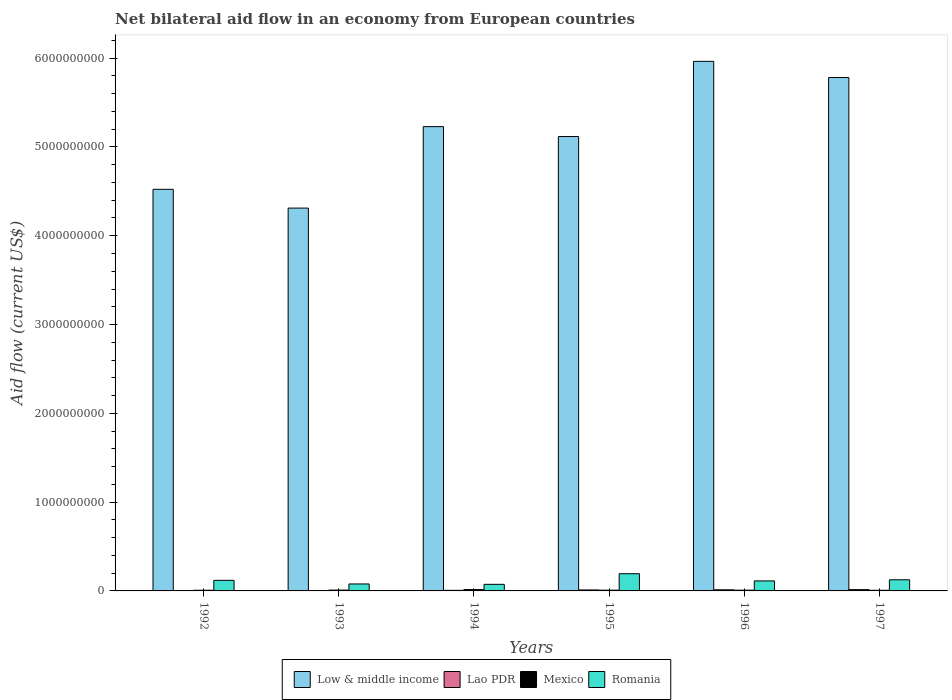How many different coloured bars are there?
Give a very brief answer. 4. How many bars are there on the 6th tick from the left?
Keep it short and to the point. 4. In how many cases, is the number of bars for a given year not equal to the number of legend labels?
Ensure brevity in your answer.  0. What is the net bilateral aid flow in Low & middle income in 1993?
Give a very brief answer. 4.31e+09. Across all years, what is the maximum net bilateral aid flow in Lao PDR?
Your answer should be very brief. 1.47e+07. Across all years, what is the minimum net bilateral aid flow in Low & middle income?
Offer a terse response. 4.31e+09. In which year was the net bilateral aid flow in Low & middle income minimum?
Provide a succinct answer. 1993. What is the total net bilateral aid flow in Mexico in the graph?
Your answer should be compact. 5.62e+07. What is the difference between the net bilateral aid flow in Lao PDR in 1995 and that in 1997?
Keep it short and to the point. -3.77e+06. What is the difference between the net bilateral aid flow in Low & middle income in 1994 and the net bilateral aid flow in Mexico in 1995?
Keep it short and to the point. 5.22e+09. What is the average net bilateral aid flow in Low & middle income per year?
Provide a short and direct response. 5.15e+09. In the year 1992, what is the difference between the net bilateral aid flow in Low & middle income and net bilateral aid flow in Romania?
Make the answer very short. 4.40e+09. In how many years, is the net bilateral aid flow in Romania greater than 5800000000 US$?
Your answer should be compact. 0. What is the ratio of the net bilateral aid flow in Lao PDR in 1995 to that in 1997?
Your answer should be very brief. 0.74. What is the difference between the highest and the second highest net bilateral aid flow in Romania?
Make the answer very short. 6.85e+07. What is the difference between the highest and the lowest net bilateral aid flow in Mexico?
Ensure brevity in your answer.  7.56e+06. In how many years, is the net bilateral aid flow in Low & middle income greater than the average net bilateral aid flow in Low & middle income taken over all years?
Ensure brevity in your answer.  3. Is the sum of the net bilateral aid flow in Mexico in 1996 and 1997 greater than the maximum net bilateral aid flow in Lao PDR across all years?
Provide a succinct answer. Yes. What does the 4th bar from the left in 1993 represents?
Your answer should be very brief. Romania. Is it the case that in every year, the sum of the net bilateral aid flow in Lao PDR and net bilateral aid flow in Mexico is greater than the net bilateral aid flow in Romania?
Ensure brevity in your answer.  No. Are all the bars in the graph horizontal?
Provide a succinct answer. No. How many years are there in the graph?
Offer a terse response. 6. What is the difference between two consecutive major ticks on the Y-axis?
Ensure brevity in your answer.  1.00e+09. What is the title of the graph?
Give a very brief answer. Net bilateral aid flow in an economy from European countries. Does "Caribbean small states" appear as one of the legend labels in the graph?
Give a very brief answer. No. What is the label or title of the Y-axis?
Offer a terse response. Aid flow (current US$). What is the Aid flow (current US$) of Low & middle income in 1992?
Provide a succinct answer. 4.52e+09. What is the Aid flow (current US$) in Lao PDR in 1992?
Make the answer very short. 3.07e+06. What is the Aid flow (current US$) in Mexico in 1992?
Make the answer very short. 7.63e+06. What is the Aid flow (current US$) of Romania in 1992?
Your answer should be very brief. 1.19e+08. What is the Aid flow (current US$) of Low & middle income in 1993?
Ensure brevity in your answer.  4.31e+09. What is the Aid flow (current US$) of Lao PDR in 1993?
Your answer should be compact. 3.56e+06. What is the Aid flow (current US$) of Mexico in 1993?
Keep it short and to the point. 9.34e+06. What is the Aid flow (current US$) in Romania in 1993?
Provide a short and direct response. 7.84e+07. What is the Aid flow (current US$) in Low & middle income in 1994?
Keep it short and to the point. 5.23e+09. What is the Aid flow (current US$) in Lao PDR in 1994?
Keep it short and to the point. 6.52e+06. What is the Aid flow (current US$) in Mexico in 1994?
Provide a short and direct response. 1.49e+07. What is the Aid flow (current US$) in Romania in 1994?
Provide a succinct answer. 7.42e+07. What is the Aid flow (current US$) in Low & middle income in 1995?
Give a very brief answer. 5.12e+09. What is the Aid flow (current US$) of Lao PDR in 1995?
Offer a terse response. 1.10e+07. What is the Aid flow (current US$) in Mexico in 1995?
Make the answer very short. 8.44e+06. What is the Aid flow (current US$) of Romania in 1995?
Your answer should be compact. 1.94e+08. What is the Aid flow (current US$) of Low & middle income in 1996?
Provide a short and direct response. 5.96e+09. What is the Aid flow (current US$) of Lao PDR in 1996?
Your response must be concise. 1.28e+07. What is the Aid flow (current US$) in Mexico in 1996?
Make the answer very short. 8.50e+06. What is the Aid flow (current US$) of Romania in 1996?
Make the answer very short. 1.13e+08. What is the Aid flow (current US$) of Low & middle income in 1997?
Your answer should be very brief. 5.78e+09. What is the Aid flow (current US$) of Lao PDR in 1997?
Keep it short and to the point. 1.47e+07. What is the Aid flow (current US$) of Mexico in 1997?
Give a very brief answer. 7.37e+06. What is the Aid flow (current US$) of Romania in 1997?
Provide a short and direct response. 1.25e+08. Across all years, what is the maximum Aid flow (current US$) of Low & middle income?
Your answer should be very brief. 5.96e+09. Across all years, what is the maximum Aid flow (current US$) in Lao PDR?
Ensure brevity in your answer.  1.47e+07. Across all years, what is the maximum Aid flow (current US$) in Mexico?
Provide a succinct answer. 1.49e+07. Across all years, what is the maximum Aid flow (current US$) of Romania?
Give a very brief answer. 1.94e+08. Across all years, what is the minimum Aid flow (current US$) in Low & middle income?
Make the answer very short. 4.31e+09. Across all years, what is the minimum Aid flow (current US$) in Lao PDR?
Provide a short and direct response. 3.07e+06. Across all years, what is the minimum Aid flow (current US$) in Mexico?
Your response must be concise. 7.37e+06. Across all years, what is the minimum Aid flow (current US$) in Romania?
Your response must be concise. 7.42e+07. What is the total Aid flow (current US$) in Low & middle income in the graph?
Offer a terse response. 3.09e+1. What is the total Aid flow (current US$) of Lao PDR in the graph?
Ensure brevity in your answer.  5.16e+07. What is the total Aid flow (current US$) in Mexico in the graph?
Offer a terse response. 5.62e+07. What is the total Aid flow (current US$) in Romania in the graph?
Your answer should be very brief. 7.04e+08. What is the difference between the Aid flow (current US$) in Low & middle income in 1992 and that in 1993?
Your answer should be compact. 2.11e+08. What is the difference between the Aid flow (current US$) of Lao PDR in 1992 and that in 1993?
Provide a short and direct response. -4.90e+05. What is the difference between the Aid flow (current US$) in Mexico in 1992 and that in 1993?
Offer a terse response. -1.71e+06. What is the difference between the Aid flow (current US$) in Romania in 1992 and that in 1993?
Give a very brief answer. 4.08e+07. What is the difference between the Aid flow (current US$) in Low & middle income in 1992 and that in 1994?
Make the answer very short. -7.06e+08. What is the difference between the Aid flow (current US$) in Lao PDR in 1992 and that in 1994?
Ensure brevity in your answer.  -3.45e+06. What is the difference between the Aid flow (current US$) in Mexico in 1992 and that in 1994?
Ensure brevity in your answer.  -7.30e+06. What is the difference between the Aid flow (current US$) in Romania in 1992 and that in 1994?
Your response must be concise. 4.50e+07. What is the difference between the Aid flow (current US$) of Low & middle income in 1992 and that in 1995?
Keep it short and to the point. -5.94e+08. What is the difference between the Aid flow (current US$) in Lao PDR in 1992 and that in 1995?
Offer a terse response. -7.88e+06. What is the difference between the Aid flow (current US$) in Mexico in 1992 and that in 1995?
Offer a very short reply. -8.10e+05. What is the difference between the Aid flow (current US$) of Romania in 1992 and that in 1995?
Provide a short and direct response. -7.46e+07. What is the difference between the Aid flow (current US$) of Low & middle income in 1992 and that in 1996?
Make the answer very short. -1.44e+09. What is the difference between the Aid flow (current US$) of Lao PDR in 1992 and that in 1996?
Provide a short and direct response. -9.73e+06. What is the difference between the Aid flow (current US$) in Mexico in 1992 and that in 1996?
Your response must be concise. -8.70e+05. What is the difference between the Aid flow (current US$) in Romania in 1992 and that in 1996?
Make the answer very short. 6.60e+06. What is the difference between the Aid flow (current US$) of Low & middle income in 1992 and that in 1997?
Make the answer very short. -1.26e+09. What is the difference between the Aid flow (current US$) of Lao PDR in 1992 and that in 1997?
Offer a very short reply. -1.16e+07. What is the difference between the Aid flow (current US$) in Mexico in 1992 and that in 1997?
Offer a very short reply. 2.60e+05. What is the difference between the Aid flow (current US$) in Romania in 1992 and that in 1997?
Give a very brief answer. -6.14e+06. What is the difference between the Aid flow (current US$) in Low & middle income in 1993 and that in 1994?
Your answer should be compact. -9.17e+08. What is the difference between the Aid flow (current US$) in Lao PDR in 1993 and that in 1994?
Make the answer very short. -2.96e+06. What is the difference between the Aid flow (current US$) in Mexico in 1993 and that in 1994?
Your answer should be very brief. -5.59e+06. What is the difference between the Aid flow (current US$) in Romania in 1993 and that in 1994?
Provide a short and direct response. 4.27e+06. What is the difference between the Aid flow (current US$) in Low & middle income in 1993 and that in 1995?
Your answer should be very brief. -8.06e+08. What is the difference between the Aid flow (current US$) in Lao PDR in 1993 and that in 1995?
Your answer should be very brief. -7.39e+06. What is the difference between the Aid flow (current US$) in Romania in 1993 and that in 1995?
Your answer should be very brief. -1.15e+08. What is the difference between the Aid flow (current US$) of Low & middle income in 1993 and that in 1996?
Your response must be concise. -1.65e+09. What is the difference between the Aid flow (current US$) in Lao PDR in 1993 and that in 1996?
Your answer should be very brief. -9.24e+06. What is the difference between the Aid flow (current US$) in Mexico in 1993 and that in 1996?
Offer a terse response. 8.40e+05. What is the difference between the Aid flow (current US$) of Romania in 1993 and that in 1996?
Offer a terse response. -3.42e+07. What is the difference between the Aid flow (current US$) in Low & middle income in 1993 and that in 1997?
Offer a terse response. -1.47e+09. What is the difference between the Aid flow (current US$) of Lao PDR in 1993 and that in 1997?
Give a very brief answer. -1.12e+07. What is the difference between the Aid flow (current US$) in Mexico in 1993 and that in 1997?
Provide a short and direct response. 1.97e+06. What is the difference between the Aid flow (current US$) in Romania in 1993 and that in 1997?
Provide a short and direct response. -4.69e+07. What is the difference between the Aid flow (current US$) in Low & middle income in 1994 and that in 1995?
Provide a succinct answer. 1.12e+08. What is the difference between the Aid flow (current US$) of Lao PDR in 1994 and that in 1995?
Your answer should be very brief. -4.43e+06. What is the difference between the Aid flow (current US$) of Mexico in 1994 and that in 1995?
Your response must be concise. 6.49e+06. What is the difference between the Aid flow (current US$) in Romania in 1994 and that in 1995?
Keep it short and to the point. -1.20e+08. What is the difference between the Aid flow (current US$) in Low & middle income in 1994 and that in 1996?
Offer a very short reply. -7.35e+08. What is the difference between the Aid flow (current US$) in Lao PDR in 1994 and that in 1996?
Offer a terse response. -6.28e+06. What is the difference between the Aid flow (current US$) of Mexico in 1994 and that in 1996?
Your response must be concise. 6.43e+06. What is the difference between the Aid flow (current US$) in Romania in 1994 and that in 1996?
Offer a terse response. -3.84e+07. What is the difference between the Aid flow (current US$) in Low & middle income in 1994 and that in 1997?
Offer a very short reply. -5.53e+08. What is the difference between the Aid flow (current US$) of Lao PDR in 1994 and that in 1997?
Offer a terse response. -8.20e+06. What is the difference between the Aid flow (current US$) in Mexico in 1994 and that in 1997?
Offer a terse response. 7.56e+06. What is the difference between the Aid flow (current US$) of Romania in 1994 and that in 1997?
Your answer should be very brief. -5.12e+07. What is the difference between the Aid flow (current US$) in Low & middle income in 1995 and that in 1996?
Make the answer very short. -8.47e+08. What is the difference between the Aid flow (current US$) of Lao PDR in 1995 and that in 1996?
Offer a terse response. -1.85e+06. What is the difference between the Aid flow (current US$) in Romania in 1995 and that in 1996?
Offer a very short reply. 8.12e+07. What is the difference between the Aid flow (current US$) of Low & middle income in 1995 and that in 1997?
Offer a very short reply. -6.64e+08. What is the difference between the Aid flow (current US$) in Lao PDR in 1995 and that in 1997?
Give a very brief answer. -3.77e+06. What is the difference between the Aid flow (current US$) in Mexico in 1995 and that in 1997?
Keep it short and to the point. 1.07e+06. What is the difference between the Aid flow (current US$) of Romania in 1995 and that in 1997?
Your answer should be very brief. 6.85e+07. What is the difference between the Aid flow (current US$) in Low & middle income in 1996 and that in 1997?
Provide a short and direct response. 1.82e+08. What is the difference between the Aid flow (current US$) in Lao PDR in 1996 and that in 1997?
Keep it short and to the point. -1.92e+06. What is the difference between the Aid flow (current US$) in Mexico in 1996 and that in 1997?
Offer a very short reply. 1.13e+06. What is the difference between the Aid flow (current US$) in Romania in 1996 and that in 1997?
Provide a short and direct response. -1.27e+07. What is the difference between the Aid flow (current US$) in Low & middle income in 1992 and the Aid flow (current US$) in Lao PDR in 1993?
Offer a terse response. 4.52e+09. What is the difference between the Aid flow (current US$) of Low & middle income in 1992 and the Aid flow (current US$) of Mexico in 1993?
Provide a short and direct response. 4.51e+09. What is the difference between the Aid flow (current US$) of Low & middle income in 1992 and the Aid flow (current US$) of Romania in 1993?
Your answer should be very brief. 4.44e+09. What is the difference between the Aid flow (current US$) in Lao PDR in 1992 and the Aid flow (current US$) in Mexico in 1993?
Provide a short and direct response. -6.27e+06. What is the difference between the Aid flow (current US$) of Lao PDR in 1992 and the Aid flow (current US$) of Romania in 1993?
Keep it short and to the point. -7.54e+07. What is the difference between the Aid flow (current US$) of Mexico in 1992 and the Aid flow (current US$) of Romania in 1993?
Your answer should be very brief. -7.08e+07. What is the difference between the Aid flow (current US$) in Low & middle income in 1992 and the Aid flow (current US$) in Lao PDR in 1994?
Provide a short and direct response. 4.52e+09. What is the difference between the Aid flow (current US$) in Low & middle income in 1992 and the Aid flow (current US$) in Mexico in 1994?
Your answer should be compact. 4.51e+09. What is the difference between the Aid flow (current US$) of Low & middle income in 1992 and the Aid flow (current US$) of Romania in 1994?
Provide a succinct answer. 4.45e+09. What is the difference between the Aid flow (current US$) of Lao PDR in 1992 and the Aid flow (current US$) of Mexico in 1994?
Keep it short and to the point. -1.19e+07. What is the difference between the Aid flow (current US$) of Lao PDR in 1992 and the Aid flow (current US$) of Romania in 1994?
Offer a terse response. -7.11e+07. What is the difference between the Aid flow (current US$) of Mexico in 1992 and the Aid flow (current US$) of Romania in 1994?
Ensure brevity in your answer.  -6.66e+07. What is the difference between the Aid flow (current US$) in Low & middle income in 1992 and the Aid flow (current US$) in Lao PDR in 1995?
Ensure brevity in your answer.  4.51e+09. What is the difference between the Aid flow (current US$) in Low & middle income in 1992 and the Aid flow (current US$) in Mexico in 1995?
Your answer should be compact. 4.51e+09. What is the difference between the Aid flow (current US$) in Low & middle income in 1992 and the Aid flow (current US$) in Romania in 1995?
Offer a terse response. 4.33e+09. What is the difference between the Aid flow (current US$) of Lao PDR in 1992 and the Aid flow (current US$) of Mexico in 1995?
Provide a short and direct response. -5.37e+06. What is the difference between the Aid flow (current US$) of Lao PDR in 1992 and the Aid flow (current US$) of Romania in 1995?
Provide a short and direct response. -1.91e+08. What is the difference between the Aid flow (current US$) of Mexico in 1992 and the Aid flow (current US$) of Romania in 1995?
Ensure brevity in your answer.  -1.86e+08. What is the difference between the Aid flow (current US$) of Low & middle income in 1992 and the Aid flow (current US$) of Lao PDR in 1996?
Your answer should be compact. 4.51e+09. What is the difference between the Aid flow (current US$) in Low & middle income in 1992 and the Aid flow (current US$) in Mexico in 1996?
Your response must be concise. 4.51e+09. What is the difference between the Aid flow (current US$) of Low & middle income in 1992 and the Aid flow (current US$) of Romania in 1996?
Offer a very short reply. 4.41e+09. What is the difference between the Aid flow (current US$) of Lao PDR in 1992 and the Aid flow (current US$) of Mexico in 1996?
Give a very brief answer. -5.43e+06. What is the difference between the Aid flow (current US$) in Lao PDR in 1992 and the Aid flow (current US$) in Romania in 1996?
Give a very brief answer. -1.10e+08. What is the difference between the Aid flow (current US$) of Mexico in 1992 and the Aid flow (current US$) of Romania in 1996?
Provide a succinct answer. -1.05e+08. What is the difference between the Aid flow (current US$) of Low & middle income in 1992 and the Aid flow (current US$) of Lao PDR in 1997?
Offer a terse response. 4.51e+09. What is the difference between the Aid flow (current US$) in Low & middle income in 1992 and the Aid flow (current US$) in Mexico in 1997?
Ensure brevity in your answer.  4.52e+09. What is the difference between the Aid flow (current US$) of Low & middle income in 1992 and the Aid flow (current US$) of Romania in 1997?
Give a very brief answer. 4.40e+09. What is the difference between the Aid flow (current US$) in Lao PDR in 1992 and the Aid flow (current US$) in Mexico in 1997?
Provide a succinct answer. -4.30e+06. What is the difference between the Aid flow (current US$) of Lao PDR in 1992 and the Aid flow (current US$) of Romania in 1997?
Provide a short and direct response. -1.22e+08. What is the difference between the Aid flow (current US$) in Mexico in 1992 and the Aid flow (current US$) in Romania in 1997?
Give a very brief answer. -1.18e+08. What is the difference between the Aid flow (current US$) in Low & middle income in 1993 and the Aid flow (current US$) in Lao PDR in 1994?
Your response must be concise. 4.30e+09. What is the difference between the Aid flow (current US$) of Low & middle income in 1993 and the Aid flow (current US$) of Mexico in 1994?
Make the answer very short. 4.30e+09. What is the difference between the Aid flow (current US$) in Low & middle income in 1993 and the Aid flow (current US$) in Romania in 1994?
Give a very brief answer. 4.24e+09. What is the difference between the Aid flow (current US$) in Lao PDR in 1993 and the Aid flow (current US$) in Mexico in 1994?
Ensure brevity in your answer.  -1.14e+07. What is the difference between the Aid flow (current US$) of Lao PDR in 1993 and the Aid flow (current US$) of Romania in 1994?
Provide a short and direct response. -7.06e+07. What is the difference between the Aid flow (current US$) of Mexico in 1993 and the Aid flow (current US$) of Romania in 1994?
Ensure brevity in your answer.  -6.48e+07. What is the difference between the Aid flow (current US$) in Low & middle income in 1993 and the Aid flow (current US$) in Lao PDR in 1995?
Your answer should be very brief. 4.30e+09. What is the difference between the Aid flow (current US$) of Low & middle income in 1993 and the Aid flow (current US$) of Mexico in 1995?
Your answer should be compact. 4.30e+09. What is the difference between the Aid flow (current US$) of Low & middle income in 1993 and the Aid flow (current US$) of Romania in 1995?
Your response must be concise. 4.12e+09. What is the difference between the Aid flow (current US$) of Lao PDR in 1993 and the Aid flow (current US$) of Mexico in 1995?
Ensure brevity in your answer.  -4.88e+06. What is the difference between the Aid flow (current US$) in Lao PDR in 1993 and the Aid flow (current US$) in Romania in 1995?
Give a very brief answer. -1.90e+08. What is the difference between the Aid flow (current US$) of Mexico in 1993 and the Aid flow (current US$) of Romania in 1995?
Provide a succinct answer. -1.85e+08. What is the difference between the Aid flow (current US$) of Low & middle income in 1993 and the Aid flow (current US$) of Lao PDR in 1996?
Make the answer very short. 4.30e+09. What is the difference between the Aid flow (current US$) of Low & middle income in 1993 and the Aid flow (current US$) of Mexico in 1996?
Offer a very short reply. 4.30e+09. What is the difference between the Aid flow (current US$) in Low & middle income in 1993 and the Aid flow (current US$) in Romania in 1996?
Your answer should be compact. 4.20e+09. What is the difference between the Aid flow (current US$) of Lao PDR in 1993 and the Aid flow (current US$) of Mexico in 1996?
Your response must be concise. -4.94e+06. What is the difference between the Aid flow (current US$) of Lao PDR in 1993 and the Aid flow (current US$) of Romania in 1996?
Give a very brief answer. -1.09e+08. What is the difference between the Aid flow (current US$) in Mexico in 1993 and the Aid flow (current US$) in Romania in 1996?
Your answer should be compact. -1.03e+08. What is the difference between the Aid flow (current US$) in Low & middle income in 1993 and the Aid flow (current US$) in Lao PDR in 1997?
Provide a succinct answer. 4.30e+09. What is the difference between the Aid flow (current US$) of Low & middle income in 1993 and the Aid flow (current US$) of Mexico in 1997?
Provide a succinct answer. 4.30e+09. What is the difference between the Aid flow (current US$) of Low & middle income in 1993 and the Aid flow (current US$) of Romania in 1997?
Ensure brevity in your answer.  4.19e+09. What is the difference between the Aid flow (current US$) in Lao PDR in 1993 and the Aid flow (current US$) in Mexico in 1997?
Your response must be concise. -3.81e+06. What is the difference between the Aid flow (current US$) of Lao PDR in 1993 and the Aid flow (current US$) of Romania in 1997?
Make the answer very short. -1.22e+08. What is the difference between the Aid flow (current US$) in Mexico in 1993 and the Aid flow (current US$) in Romania in 1997?
Make the answer very short. -1.16e+08. What is the difference between the Aid flow (current US$) in Low & middle income in 1994 and the Aid flow (current US$) in Lao PDR in 1995?
Provide a succinct answer. 5.22e+09. What is the difference between the Aid flow (current US$) of Low & middle income in 1994 and the Aid flow (current US$) of Mexico in 1995?
Offer a very short reply. 5.22e+09. What is the difference between the Aid flow (current US$) in Low & middle income in 1994 and the Aid flow (current US$) in Romania in 1995?
Your answer should be very brief. 5.03e+09. What is the difference between the Aid flow (current US$) in Lao PDR in 1994 and the Aid flow (current US$) in Mexico in 1995?
Offer a terse response. -1.92e+06. What is the difference between the Aid flow (current US$) of Lao PDR in 1994 and the Aid flow (current US$) of Romania in 1995?
Make the answer very short. -1.87e+08. What is the difference between the Aid flow (current US$) in Mexico in 1994 and the Aid flow (current US$) in Romania in 1995?
Your answer should be compact. -1.79e+08. What is the difference between the Aid flow (current US$) in Low & middle income in 1994 and the Aid flow (current US$) in Lao PDR in 1996?
Offer a very short reply. 5.22e+09. What is the difference between the Aid flow (current US$) of Low & middle income in 1994 and the Aid flow (current US$) of Mexico in 1996?
Offer a terse response. 5.22e+09. What is the difference between the Aid flow (current US$) of Low & middle income in 1994 and the Aid flow (current US$) of Romania in 1996?
Keep it short and to the point. 5.12e+09. What is the difference between the Aid flow (current US$) in Lao PDR in 1994 and the Aid flow (current US$) in Mexico in 1996?
Your response must be concise. -1.98e+06. What is the difference between the Aid flow (current US$) in Lao PDR in 1994 and the Aid flow (current US$) in Romania in 1996?
Provide a short and direct response. -1.06e+08. What is the difference between the Aid flow (current US$) in Mexico in 1994 and the Aid flow (current US$) in Romania in 1996?
Offer a terse response. -9.77e+07. What is the difference between the Aid flow (current US$) in Low & middle income in 1994 and the Aid flow (current US$) in Lao PDR in 1997?
Give a very brief answer. 5.21e+09. What is the difference between the Aid flow (current US$) of Low & middle income in 1994 and the Aid flow (current US$) of Mexico in 1997?
Offer a terse response. 5.22e+09. What is the difference between the Aid flow (current US$) in Low & middle income in 1994 and the Aid flow (current US$) in Romania in 1997?
Offer a terse response. 5.10e+09. What is the difference between the Aid flow (current US$) in Lao PDR in 1994 and the Aid flow (current US$) in Mexico in 1997?
Offer a terse response. -8.50e+05. What is the difference between the Aid flow (current US$) in Lao PDR in 1994 and the Aid flow (current US$) in Romania in 1997?
Keep it short and to the point. -1.19e+08. What is the difference between the Aid flow (current US$) of Mexico in 1994 and the Aid flow (current US$) of Romania in 1997?
Provide a short and direct response. -1.10e+08. What is the difference between the Aid flow (current US$) in Low & middle income in 1995 and the Aid flow (current US$) in Lao PDR in 1996?
Your response must be concise. 5.10e+09. What is the difference between the Aid flow (current US$) of Low & middle income in 1995 and the Aid flow (current US$) of Mexico in 1996?
Offer a very short reply. 5.11e+09. What is the difference between the Aid flow (current US$) of Low & middle income in 1995 and the Aid flow (current US$) of Romania in 1996?
Your response must be concise. 5.00e+09. What is the difference between the Aid flow (current US$) of Lao PDR in 1995 and the Aid flow (current US$) of Mexico in 1996?
Provide a short and direct response. 2.45e+06. What is the difference between the Aid flow (current US$) in Lao PDR in 1995 and the Aid flow (current US$) in Romania in 1996?
Give a very brief answer. -1.02e+08. What is the difference between the Aid flow (current US$) in Mexico in 1995 and the Aid flow (current US$) in Romania in 1996?
Your response must be concise. -1.04e+08. What is the difference between the Aid flow (current US$) in Low & middle income in 1995 and the Aid flow (current US$) in Lao PDR in 1997?
Your answer should be compact. 5.10e+09. What is the difference between the Aid flow (current US$) of Low & middle income in 1995 and the Aid flow (current US$) of Mexico in 1997?
Offer a very short reply. 5.11e+09. What is the difference between the Aid flow (current US$) of Low & middle income in 1995 and the Aid flow (current US$) of Romania in 1997?
Provide a succinct answer. 4.99e+09. What is the difference between the Aid flow (current US$) of Lao PDR in 1995 and the Aid flow (current US$) of Mexico in 1997?
Provide a short and direct response. 3.58e+06. What is the difference between the Aid flow (current US$) of Lao PDR in 1995 and the Aid flow (current US$) of Romania in 1997?
Your answer should be very brief. -1.14e+08. What is the difference between the Aid flow (current US$) in Mexico in 1995 and the Aid flow (current US$) in Romania in 1997?
Provide a short and direct response. -1.17e+08. What is the difference between the Aid flow (current US$) in Low & middle income in 1996 and the Aid flow (current US$) in Lao PDR in 1997?
Provide a short and direct response. 5.95e+09. What is the difference between the Aid flow (current US$) in Low & middle income in 1996 and the Aid flow (current US$) in Mexico in 1997?
Offer a very short reply. 5.96e+09. What is the difference between the Aid flow (current US$) of Low & middle income in 1996 and the Aid flow (current US$) of Romania in 1997?
Make the answer very short. 5.84e+09. What is the difference between the Aid flow (current US$) in Lao PDR in 1996 and the Aid flow (current US$) in Mexico in 1997?
Make the answer very short. 5.43e+06. What is the difference between the Aid flow (current US$) in Lao PDR in 1996 and the Aid flow (current US$) in Romania in 1997?
Offer a very short reply. -1.13e+08. What is the difference between the Aid flow (current US$) in Mexico in 1996 and the Aid flow (current US$) in Romania in 1997?
Keep it short and to the point. -1.17e+08. What is the average Aid flow (current US$) of Low & middle income per year?
Provide a short and direct response. 5.15e+09. What is the average Aid flow (current US$) of Lao PDR per year?
Provide a succinct answer. 8.60e+06. What is the average Aid flow (current US$) in Mexico per year?
Provide a succinct answer. 9.37e+06. What is the average Aid flow (current US$) of Romania per year?
Ensure brevity in your answer.  1.17e+08. In the year 1992, what is the difference between the Aid flow (current US$) in Low & middle income and Aid flow (current US$) in Lao PDR?
Your response must be concise. 4.52e+09. In the year 1992, what is the difference between the Aid flow (current US$) of Low & middle income and Aid flow (current US$) of Mexico?
Your response must be concise. 4.52e+09. In the year 1992, what is the difference between the Aid flow (current US$) of Low & middle income and Aid flow (current US$) of Romania?
Your response must be concise. 4.40e+09. In the year 1992, what is the difference between the Aid flow (current US$) in Lao PDR and Aid flow (current US$) in Mexico?
Provide a succinct answer. -4.56e+06. In the year 1992, what is the difference between the Aid flow (current US$) of Lao PDR and Aid flow (current US$) of Romania?
Offer a terse response. -1.16e+08. In the year 1992, what is the difference between the Aid flow (current US$) in Mexico and Aid flow (current US$) in Romania?
Provide a succinct answer. -1.12e+08. In the year 1993, what is the difference between the Aid flow (current US$) of Low & middle income and Aid flow (current US$) of Lao PDR?
Offer a very short reply. 4.31e+09. In the year 1993, what is the difference between the Aid flow (current US$) in Low & middle income and Aid flow (current US$) in Mexico?
Offer a very short reply. 4.30e+09. In the year 1993, what is the difference between the Aid flow (current US$) of Low & middle income and Aid flow (current US$) of Romania?
Your answer should be compact. 4.23e+09. In the year 1993, what is the difference between the Aid flow (current US$) in Lao PDR and Aid flow (current US$) in Mexico?
Your answer should be compact. -5.78e+06. In the year 1993, what is the difference between the Aid flow (current US$) in Lao PDR and Aid flow (current US$) in Romania?
Keep it short and to the point. -7.49e+07. In the year 1993, what is the difference between the Aid flow (current US$) in Mexico and Aid flow (current US$) in Romania?
Keep it short and to the point. -6.91e+07. In the year 1994, what is the difference between the Aid flow (current US$) in Low & middle income and Aid flow (current US$) in Lao PDR?
Offer a terse response. 5.22e+09. In the year 1994, what is the difference between the Aid flow (current US$) of Low & middle income and Aid flow (current US$) of Mexico?
Ensure brevity in your answer.  5.21e+09. In the year 1994, what is the difference between the Aid flow (current US$) in Low & middle income and Aid flow (current US$) in Romania?
Provide a short and direct response. 5.15e+09. In the year 1994, what is the difference between the Aid flow (current US$) in Lao PDR and Aid flow (current US$) in Mexico?
Offer a very short reply. -8.41e+06. In the year 1994, what is the difference between the Aid flow (current US$) in Lao PDR and Aid flow (current US$) in Romania?
Ensure brevity in your answer.  -6.77e+07. In the year 1994, what is the difference between the Aid flow (current US$) in Mexico and Aid flow (current US$) in Romania?
Keep it short and to the point. -5.92e+07. In the year 1995, what is the difference between the Aid flow (current US$) of Low & middle income and Aid flow (current US$) of Lao PDR?
Your answer should be compact. 5.11e+09. In the year 1995, what is the difference between the Aid flow (current US$) in Low & middle income and Aid flow (current US$) in Mexico?
Make the answer very short. 5.11e+09. In the year 1995, what is the difference between the Aid flow (current US$) of Low & middle income and Aid flow (current US$) of Romania?
Offer a terse response. 4.92e+09. In the year 1995, what is the difference between the Aid flow (current US$) of Lao PDR and Aid flow (current US$) of Mexico?
Provide a short and direct response. 2.51e+06. In the year 1995, what is the difference between the Aid flow (current US$) in Lao PDR and Aid flow (current US$) in Romania?
Your response must be concise. -1.83e+08. In the year 1995, what is the difference between the Aid flow (current US$) in Mexico and Aid flow (current US$) in Romania?
Provide a succinct answer. -1.85e+08. In the year 1996, what is the difference between the Aid flow (current US$) of Low & middle income and Aid flow (current US$) of Lao PDR?
Your response must be concise. 5.95e+09. In the year 1996, what is the difference between the Aid flow (current US$) of Low & middle income and Aid flow (current US$) of Mexico?
Ensure brevity in your answer.  5.96e+09. In the year 1996, what is the difference between the Aid flow (current US$) of Low & middle income and Aid flow (current US$) of Romania?
Your answer should be very brief. 5.85e+09. In the year 1996, what is the difference between the Aid flow (current US$) in Lao PDR and Aid flow (current US$) in Mexico?
Provide a succinct answer. 4.30e+06. In the year 1996, what is the difference between the Aid flow (current US$) of Lao PDR and Aid flow (current US$) of Romania?
Offer a terse response. -9.98e+07. In the year 1996, what is the difference between the Aid flow (current US$) in Mexico and Aid flow (current US$) in Romania?
Give a very brief answer. -1.04e+08. In the year 1997, what is the difference between the Aid flow (current US$) in Low & middle income and Aid flow (current US$) in Lao PDR?
Give a very brief answer. 5.77e+09. In the year 1997, what is the difference between the Aid flow (current US$) in Low & middle income and Aid flow (current US$) in Mexico?
Offer a terse response. 5.77e+09. In the year 1997, what is the difference between the Aid flow (current US$) in Low & middle income and Aid flow (current US$) in Romania?
Give a very brief answer. 5.66e+09. In the year 1997, what is the difference between the Aid flow (current US$) in Lao PDR and Aid flow (current US$) in Mexico?
Provide a succinct answer. 7.35e+06. In the year 1997, what is the difference between the Aid flow (current US$) in Lao PDR and Aid flow (current US$) in Romania?
Give a very brief answer. -1.11e+08. In the year 1997, what is the difference between the Aid flow (current US$) in Mexico and Aid flow (current US$) in Romania?
Your answer should be compact. -1.18e+08. What is the ratio of the Aid flow (current US$) of Low & middle income in 1992 to that in 1993?
Keep it short and to the point. 1.05. What is the ratio of the Aid flow (current US$) in Lao PDR in 1992 to that in 1993?
Offer a very short reply. 0.86. What is the ratio of the Aid flow (current US$) of Mexico in 1992 to that in 1993?
Provide a short and direct response. 0.82. What is the ratio of the Aid flow (current US$) in Romania in 1992 to that in 1993?
Provide a short and direct response. 1.52. What is the ratio of the Aid flow (current US$) of Low & middle income in 1992 to that in 1994?
Offer a terse response. 0.86. What is the ratio of the Aid flow (current US$) in Lao PDR in 1992 to that in 1994?
Provide a succinct answer. 0.47. What is the ratio of the Aid flow (current US$) of Mexico in 1992 to that in 1994?
Offer a terse response. 0.51. What is the ratio of the Aid flow (current US$) of Romania in 1992 to that in 1994?
Make the answer very short. 1.61. What is the ratio of the Aid flow (current US$) of Low & middle income in 1992 to that in 1995?
Ensure brevity in your answer.  0.88. What is the ratio of the Aid flow (current US$) in Lao PDR in 1992 to that in 1995?
Provide a succinct answer. 0.28. What is the ratio of the Aid flow (current US$) in Mexico in 1992 to that in 1995?
Keep it short and to the point. 0.9. What is the ratio of the Aid flow (current US$) in Romania in 1992 to that in 1995?
Ensure brevity in your answer.  0.61. What is the ratio of the Aid flow (current US$) of Low & middle income in 1992 to that in 1996?
Offer a terse response. 0.76. What is the ratio of the Aid flow (current US$) of Lao PDR in 1992 to that in 1996?
Your answer should be very brief. 0.24. What is the ratio of the Aid flow (current US$) in Mexico in 1992 to that in 1996?
Your answer should be very brief. 0.9. What is the ratio of the Aid flow (current US$) of Romania in 1992 to that in 1996?
Your response must be concise. 1.06. What is the ratio of the Aid flow (current US$) in Low & middle income in 1992 to that in 1997?
Provide a short and direct response. 0.78. What is the ratio of the Aid flow (current US$) of Lao PDR in 1992 to that in 1997?
Keep it short and to the point. 0.21. What is the ratio of the Aid flow (current US$) in Mexico in 1992 to that in 1997?
Your answer should be compact. 1.04. What is the ratio of the Aid flow (current US$) in Romania in 1992 to that in 1997?
Ensure brevity in your answer.  0.95. What is the ratio of the Aid flow (current US$) of Low & middle income in 1993 to that in 1994?
Ensure brevity in your answer.  0.82. What is the ratio of the Aid flow (current US$) in Lao PDR in 1993 to that in 1994?
Your response must be concise. 0.55. What is the ratio of the Aid flow (current US$) of Mexico in 1993 to that in 1994?
Provide a short and direct response. 0.63. What is the ratio of the Aid flow (current US$) in Romania in 1993 to that in 1994?
Your answer should be compact. 1.06. What is the ratio of the Aid flow (current US$) in Low & middle income in 1993 to that in 1995?
Provide a succinct answer. 0.84. What is the ratio of the Aid flow (current US$) of Lao PDR in 1993 to that in 1995?
Your answer should be very brief. 0.33. What is the ratio of the Aid flow (current US$) of Mexico in 1993 to that in 1995?
Keep it short and to the point. 1.11. What is the ratio of the Aid flow (current US$) of Romania in 1993 to that in 1995?
Provide a succinct answer. 0.4. What is the ratio of the Aid flow (current US$) of Low & middle income in 1993 to that in 1996?
Make the answer very short. 0.72. What is the ratio of the Aid flow (current US$) of Lao PDR in 1993 to that in 1996?
Your response must be concise. 0.28. What is the ratio of the Aid flow (current US$) of Mexico in 1993 to that in 1996?
Your response must be concise. 1.1. What is the ratio of the Aid flow (current US$) of Romania in 1993 to that in 1996?
Provide a succinct answer. 0.7. What is the ratio of the Aid flow (current US$) of Low & middle income in 1993 to that in 1997?
Keep it short and to the point. 0.75. What is the ratio of the Aid flow (current US$) of Lao PDR in 1993 to that in 1997?
Give a very brief answer. 0.24. What is the ratio of the Aid flow (current US$) in Mexico in 1993 to that in 1997?
Offer a very short reply. 1.27. What is the ratio of the Aid flow (current US$) in Romania in 1993 to that in 1997?
Offer a very short reply. 0.63. What is the ratio of the Aid flow (current US$) in Low & middle income in 1994 to that in 1995?
Your answer should be very brief. 1.02. What is the ratio of the Aid flow (current US$) of Lao PDR in 1994 to that in 1995?
Provide a succinct answer. 0.6. What is the ratio of the Aid flow (current US$) in Mexico in 1994 to that in 1995?
Your response must be concise. 1.77. What is the ratio of the Aid flow (current US$) of Romania in 1994 to that in 1995?
Offer a terse response. 0.38. What is the ratio of the Aid flow (current US$) in Low & middle income in 1994 to that in 1996?
Your answer should be very brief. 0.88. What is the ratio of the Aid flow (current US$) of Lao PDR in 1994 to that in 1996?
Give a very brief answer. 0.51. What is the ratio of the Aid flow (current US$) in Mexico in 1994 to that in 1996?
Offer a very short reply. 1.76. What is the ratio of the Aid flow (current US$) in Romania in 1994 to that in 1996?
Offer a terse response. 0.66. What is the ratio of the Aid flow (current US$) of Low & middle income in 1994 to that in 1997?
Make the answer very short. 0.9. What is the ratio of the Aid flow (current US$) in Lao PDR in 1994 to that in 1997?
Offer a terse response. 0.44. What is the ratio of the Aid flow (current US$) in Mexico in 1994 to that in 1997?
Ensure brevity in your answer.  2.03. What is the ratio of the Aid flow (current US$) of Romania in 1994 to that in 1997?
Offer a terse response. 0.59. What is the ratio of the Aid flow (current US$) of Low & middle income in 1995 to that in 1996?
Your answer should be compact. 0.86. What is the ratio of the Aid flow (current US$) of Lao PDR in 1995 to that in 1996?
Your answer should be very brief. 0.86. What is the ratio of the Aid flow (current US$) in Romania in 1995 to that in 1996?
Your response must be concise. 1.72. What is the ratio of the Aid flow (current US$) of Low & middle income in 1995 to that in 1997?
Offer a terse response. 0.89. What is the ratio of the Aid flow (current US$) of Lao PDR in 1995 to that in 1997?
Keep it short and to the point. 0.74. What is the ratio of the Aid flow (current US$) of Mexico in 1995 to that in 1997?
Your answer should be compact. 1.15. What is the ratio of the Aid flow (current US$) in Romania in 1995 to that in 1997?
Your answer should be compact. 1.55. What is the ratio of the Aid flow (current US$) of Low & middle income in 1996 to that in 1997?
Offer a terse response. 1.03. What is the ratio of the Aid flow (current US$) in Lao PDR in 1996 to that in 1997?
Your answer should be compact. 0.87. What is the ratio of the Aid flow (current US$) of Mexico in 1996 to that in 1997?
Ensure brevity in your answer.  1.15. What is the ratio of the Aid flow (current US$) of Romania in 1996 to that in 1997?
Keep it short and to the point. 0.9. What is the difference between the highest and the second highest Aid flow (current US$) of Low & middle income?
Your response must be concise. 1.82e+08. What is the difference between the highest and the second highest Aid flow (current US$) of Lao PDR?
Your response must be concise. 1.92e+06. What is the difference between the highest and the second highest Aid flow (current US$) of Mexico?
Your answer should be very brief. 5.59e+06. What is the difference between the highest and the second highest Aid flow (current US$) of Romania?
Your answer should be very brief. 6.85e+07. What is the difference between the highest and the lowest Aid flow (current US$) of Low & middle income?
Give a very brief answer. 1.65e+09. What is the difference between the highest and the lowest Aid flow (current US$) of Lao PDR?
Keep it short and to the point. 1.16e+07. What is the difference between the highest and the lowest Aid flow (current US$) in Mexico?
Keep it short and to the point. 7.56e+06. What is the difference between the highest and the lowest Aid flow (current US$) in Romania?
Provide a short and direct response. 1.20e+08. 